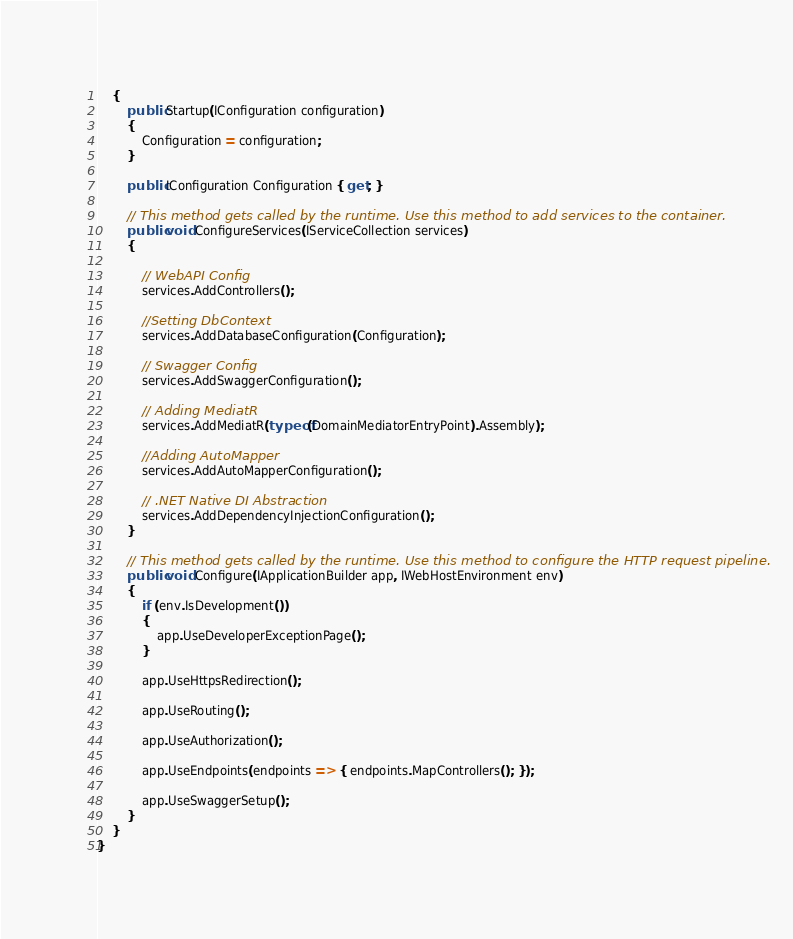Convert code to text. <code><loc_0><loc_0><loc_500><loc_500><_C#_>    {
        public Startup(IConfiguration configuration)
        {
            Configuration = configuration;
        }

        public IConfiguration Configuration { get; }

        // This method gets called by the runtime. Use this method to add services to the container.
        public void ConfigureServices(IServiceCollection services)
        {
            
            // WebAPI Config
            services.AddControllers();
            
            //Setting DbContext 
            services.AddDatabaseConfiguration(Configuration);
            
            // Swagger Config
            services.AddSwaggerConfiguration();        
            
            // Adding MediatR
            services.AddMediatR(typeof(DomainMediatorEntryPoint).Assembly);
            
            //Adding AutoMapper
            services.AddAutoMapperConfiguration();

            // .NET Native DI Abstraction
            services.AddDependencyInjectionConfiguration();
        }

        // This method gets called by the runtime. Use this method to configure the HTTP request pipeline.
        public void Configure(IApplicationBuilder app, IWebHostEnvironment env)
        {
            if (env.IsDevelopment())
            {
                app.UseDeveloperExceptionPage();
            }

            app.UseHttpsRedirection();

            app.UseRouting();

            app.UseAuthorization();

            app.UseEndpoints(endpoints => { endpoints.MapControllers(); });
            
            app.UseSwaggerSetup();
        }
    }
}</code> 